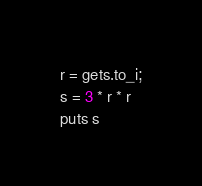<code> <loc_0><loc_0><loc_500><loc_500><_Ruby_>r = gets.to_i;
s = 3 * r * r
puts s</code> 